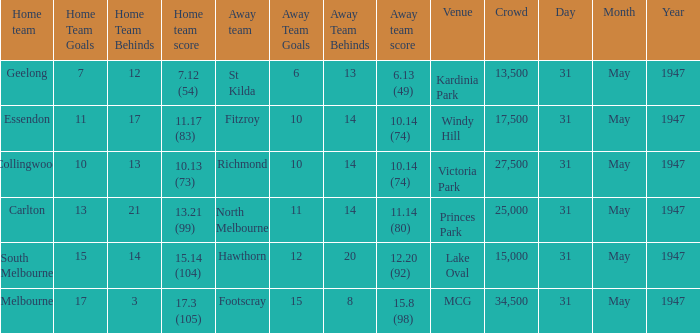Could you help me parse every detail presented in this table? {'header': ['Home team', 'Home Team Goals', 'Home Team Behinds', 'Home team score', 'Away team', 'Away Team Goals', 'Away Team Behinds', 'Away team score', 'Venue', 'Crowd', 'Day', 'Month', 'Year'], 'rows': [['Geelong', '7', '12', '7.12 (54)', 'St Kilda', '6', '13', '6.13 (49)', 'Kardinia Park', '13,500', '31', 'May', '1947'], ['Essendon', '11', '17', '11.17 (83)', 'Fitzroy', '10', '14', '10.14 (74)', 'Windy Hill', '17,500', '31', 'May', '1947'], ['Collingwood', '10', '13', '10.13 (73)', 'Richmond', '10', '14', '10.14 (74)', 'Victoria Park', '27,500', '31', 'May', '1947'], ['Carlton', '13', '21', '13.21 (99)', 'North Melbourne', '11', '14', '11.14 (80)', 'Princes Park', '25,000', '31', 'May', '1947'], ['South Melbourne', '15', '14', '15.14 (104)', 'Hawthorn', '12', '20', '12.20 (92)', 'Lake Oval', '15,000', '31', 'May', '1947'], ['Melbourne', '17', '3', '17.3 (105)', 'Footscray', '15', '8', '15.8 (98)', 'MCG', '34,500', '31', 'May', '1947']]} What is the listed crowd when hawthorn is away? 1.0. 